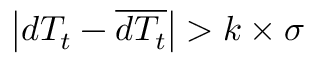Convert formula to latex. <formula><loc_0><loc_0><loc_500><loc_500>\left | d T _ { t } - \overline { { d T _ { t } } } \right | > k \times \sigma</formula> 